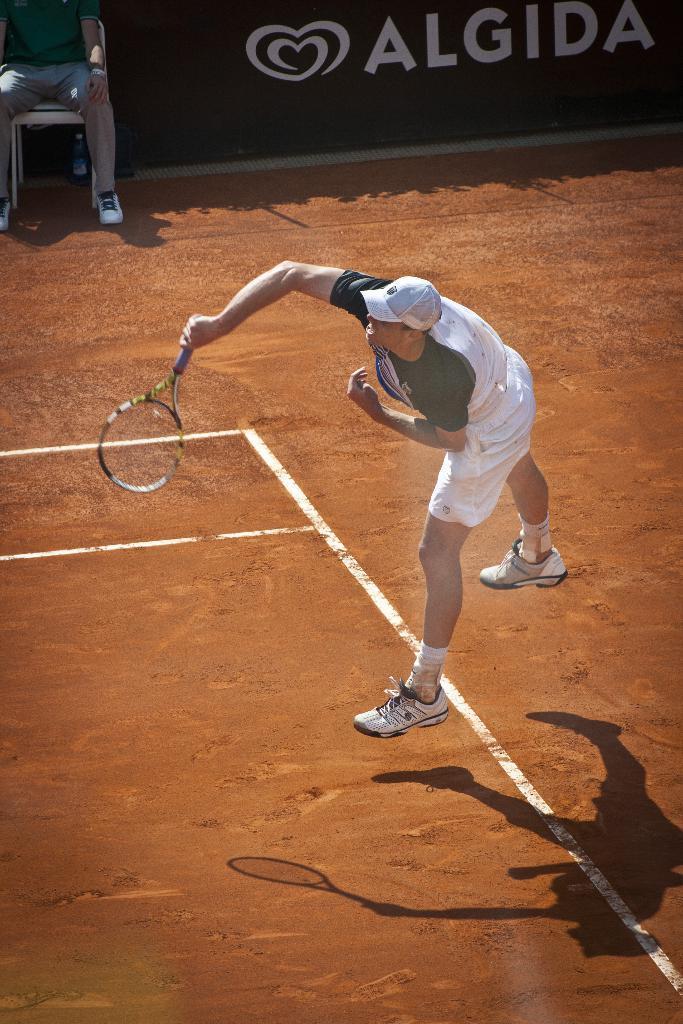Can you describe this image briefly? This image is taken outdoors. At the bottom of the image there is a ground. In the background there is a board with a text on it and a person is sitting on the chair. In the middle of the image a man is playing tennis. He is holding a bat in his hand. 